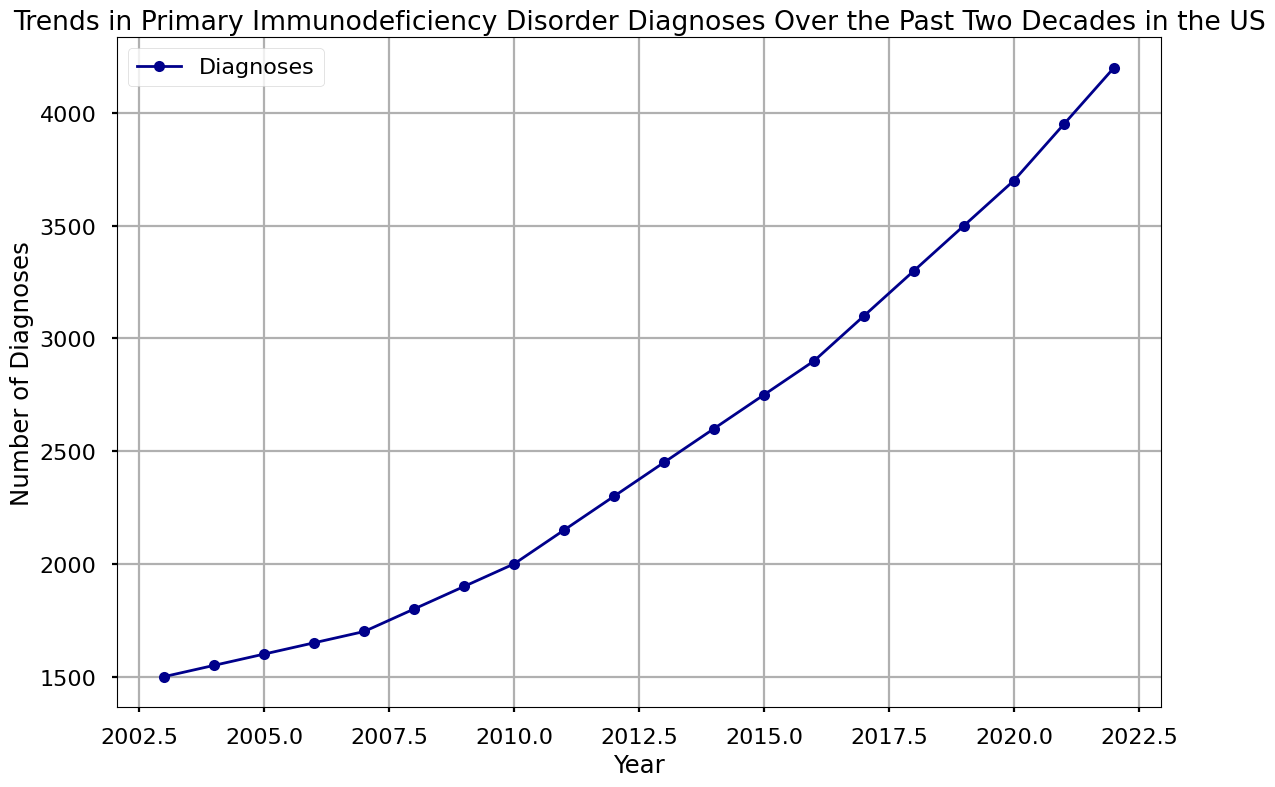What is the trend of Primary Immunodeficiency Disorder Diagnoses from 2003 to 2022? The line chart shows a consistent upward trend from 2003 to 2022, indicating an overall increase in the number of diagnoses each year.
Answer: Upward trend How many more diagnoses were there in 2022 compared to 2003? The number of diagnoses in 2022 was 4200, and in 2003 it was 1500. The difference is calculated as 4200 - 1500.
Answer: 2700 Between which years did the number of diagnoses have the largest increase? By examining the rise in the line chart, we notice that the steepest increase is between 2021 and 2022 where the diagnoses increased from 3950 to 4200.
Answer: 2021 to 2022 What is the average annual number of diagnoses over the two decades? Sum all annual diagnoses and divide by the number of years. The total sum is 59750, and there are 20 years. Thus, the average is 59750 / 20.
Answer: 2987.5 Between which consecutive years did the smallest increase in diagnoses occur? By comparing the changes year-to-year, the smallest increase in diagnoses happened between 2006 and 2007, where it increased by 50 from 1650 to 1700.
Answer: 2006 to 2007 What is the percentage increase in diagnoses from 2006 to 2022? Compute the increase from 2006 to 2022, which is 4200 - 1650 = 2550. Then, calculate the percentage increase as (2550 / 1650) * 100.
Answer: 154.55% Which year had exactly 3000 diagnoses? Visual inspection of the line chart shows that there was no year with exactly 3000 diagnoses; the closest is around 2017.
Answer: None How did the number of diagnoses change from 2009 to 2011? The diagnoses increased from 1900 in 2009 to 2150 in 2011. The increment is 2150 - 1900.
Answer: 250 Is there any year where the number of diagnoses decreased compared to the previous year? The line chart shows a consistent upward trend with no decreases; every subsequent year has more diagnoses than the year before.
Answer: No 